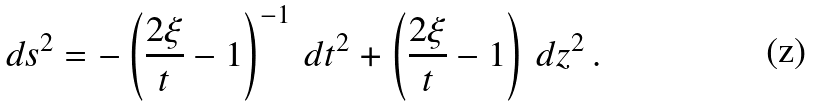<formula> <loc_0><loc_0><loc_500><loc_500>d s ^ { 2 } = - \left ( \frac { 2 \xi } { t } - 1 \right ) ^ { - 1 } \, d t ^ { 2 } + \left ( \frac { 2 \xi } { t } - 1 \right ) \, d z ^ { 2 } \, .</formula> 